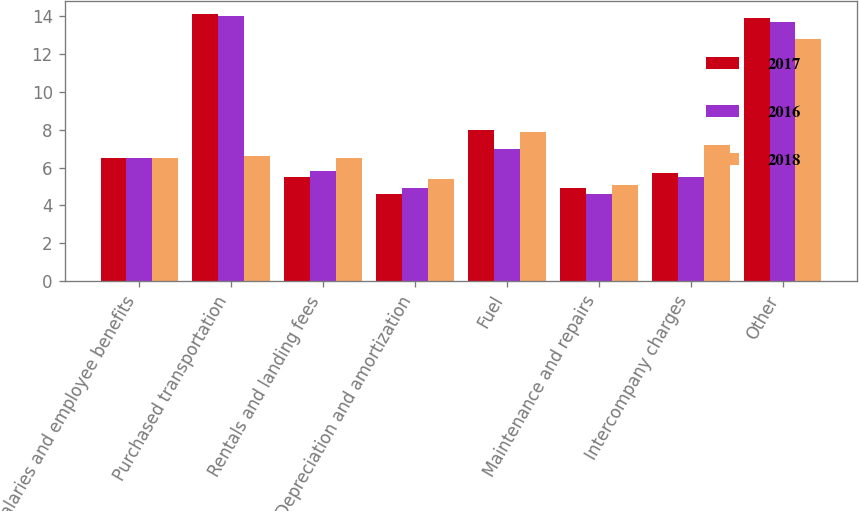Convert chart. <chart><loc_0><loc_0><loc_500><loc_500><stacked_bar_chart><ecel><fcel>Salaries and employee benefits<fcel>Purchased transportation<fcel>Rentals and landing fees<fcel>Depreciation and amortization<fcel>Fuel<fcel>Maintenance and repairs<fcel>Intercompany charges<fcel>Other<nl><fcel>2017<fcel>6.5<fcel>14.1<fcel>5.5<fcel>4.6<fcel>8<fcel>4.9<fcel>5.7<fcel>13.9<nl><fcel>2016<fcel>6.5<fcel>14<fcel>5.8<fcel>4.9<fcel>7<fcel>4.6<fcel>5.5<fcel>13.7<nl><fcel>2018<fcel>6.5<fcel>6.6<fcel>6.5<fcel>5.4<fcel>7.9<fcel>5.1<fcel>7.2<fcel>12.8<nl></chart> 